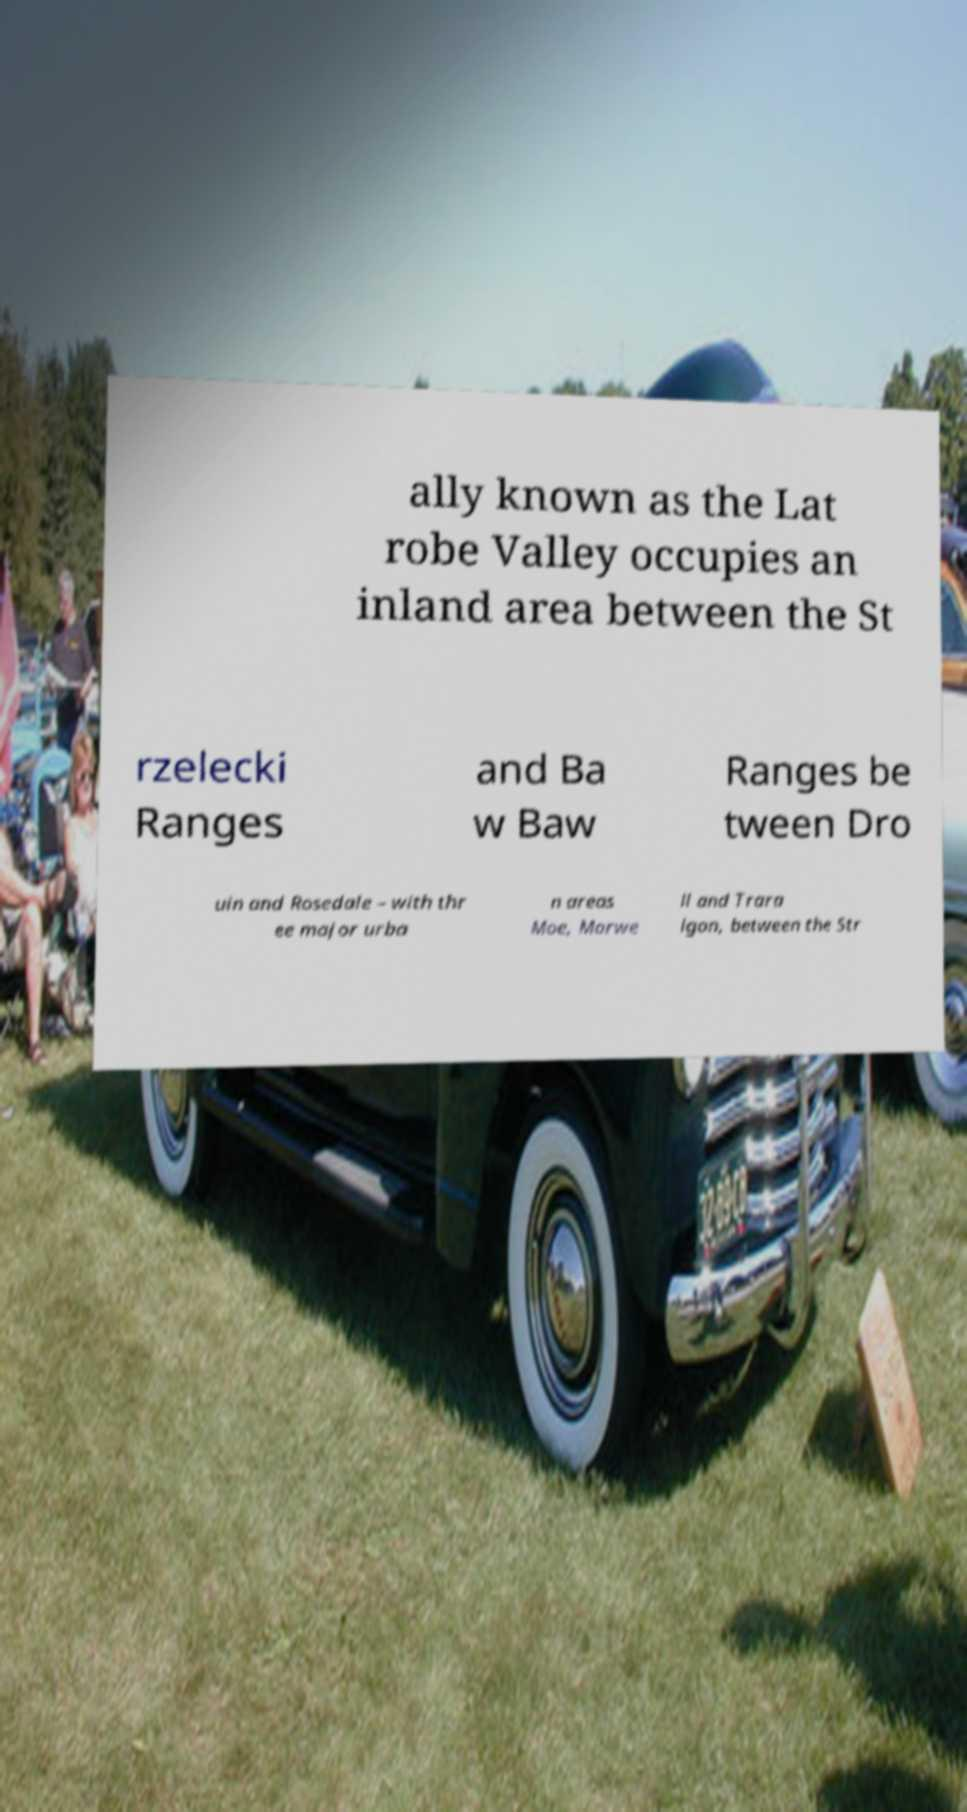Please read and relay the text visible in this image. What does it say? ally known as the Lat robe Valley occupies an inland area between the St rzelecki Ranges and Ba w Baw Ranges be tween Dro uin and Rosedale – with thr ee major urba n areas Moe, Morwe ll and Trara lgon, between the Str 